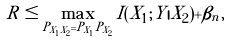Convert formula to latex. <formula><loc_0><loc_0><loc_500><loc_500>R \leq \max _ { P _ { X _ { 1 } X _ { 2 } } = P _ { X _ { 1 } } P _ { X _ { 2 } } } I ( X _ { 1 } ; Y | X _ { 2 } ) + \beta _ { n } ,</formula> 